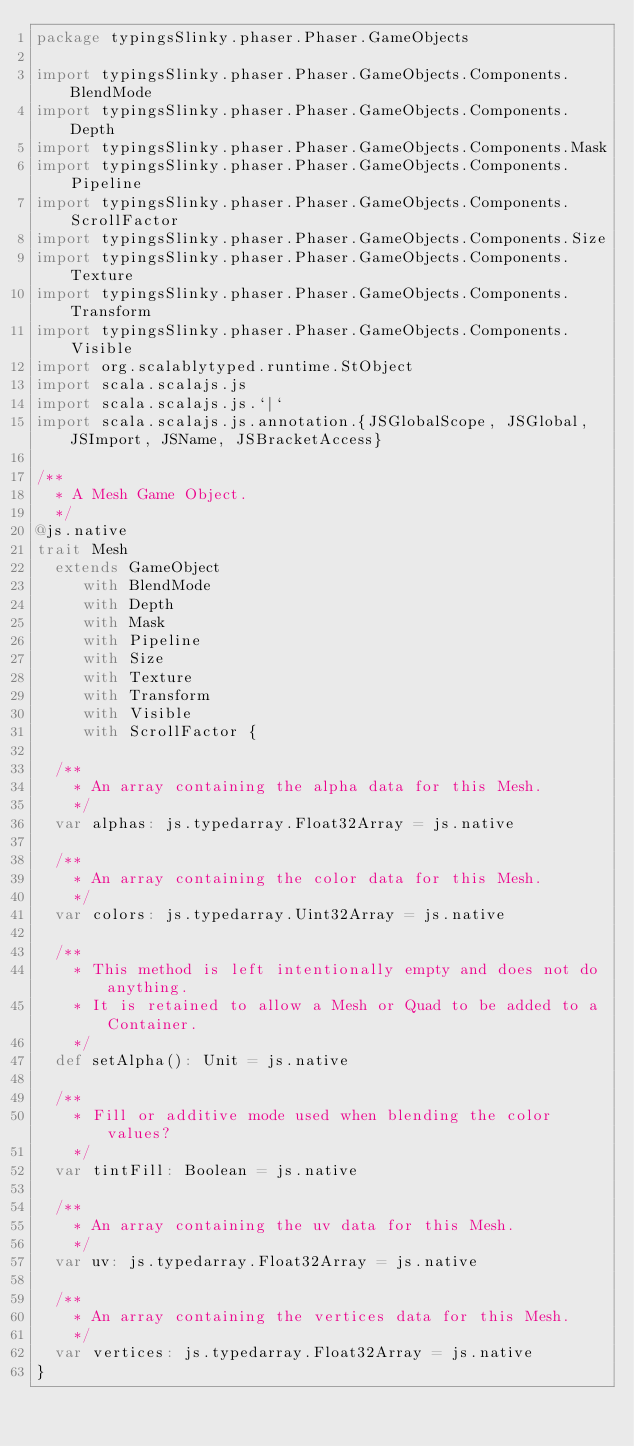Convert code to text. <code><loc_0><loc_0><loc_500><loc_500><_Scala_>package typingsSlinky.phaser.Phaser.GameObjects

import typingsSlinky.phaser.Phaser.GameObjects.Components.BlendMode
import typingsSlinky.phaser.Phaser.GameObjects.Components.Depth
import typingsSlinky.phaser.Phaser.GameObjects.Components.Mask
import typingsSlinky.phaser.Phaser.GameObjects.Components.Pipeline
import typingsSlinky.phaser.Phaser.GameObjects.Components.ScrollFactor
import typingsSlinky.phaser.Phaser.GameObjects.Components.Size
import typingsSlinky.phaser.Phaser.GameObjects.Components.Texture
import typingsSlinky.phaser.Phaser.GameObjects.Components.Transform
import typingsSlinky.phaser.Phaser.GameObjects.Components.Visible
import org.scalablytyped.runtime.StObject
import scala.scalajs.js
import scala.scalajs.js.`|`
import scala.scalajs.js.annotation.{JSGlobalScope, JSGlobal, JSImport, JSName, JSBracketAccess}

/**
  * A Mesh Game Object.
  */
@js.native
trait Mesh
  extends GameObject
     with BlendMode
     with Depth
     with Mask
     with Pipeline
     with Size
     with Texture
     with Transform
     with Visible
     with ScrollFactor {
  
  /**
    * An array containing the alpha data for this Mesh.
    */
  var alphas: js.typedarray.Float32Array = js.native
  
  /**
    * An array containing the color data for this Mesh.
    */
  var colors: js.typedarray.Uint32Array = js.native
  
  /**
    * This method is left intentionally empty and does not do anything.
    * It is retained to allow a Mesh or Quad to be added to a Container.
    */
  def setAlpha(): Unit = js.native
  
  /**
    * Fill or additive mode used when blending the color values?
    */
  var tintFill: Boolean = js.native
  
  /**
    * An array containing the uv data for this Mesh.
    */
  var uv: js.typedarray.Float32Array = js.native
  
  /**
    * An array containing the vertices data for this Mesh.
    */
  var vertices: js.typedarray.Float32Array = js.native
}
</code> 